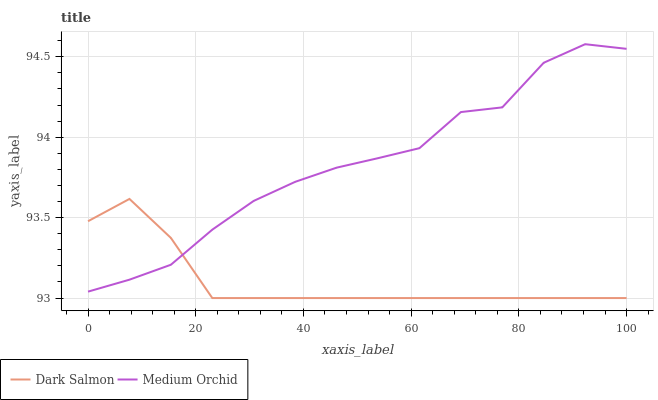Does Dark Salmon have the minimum area under the curve?
Answer yes or no. Yes. Does Medium Orchid have the maximum area under the curve?
Answer yes or no. Yes. Does Dark Salmon have the maximum area under the curve?
Answer yes or no. No. Is Dark Salmon the smoothest?
Answer yes or no. Yes. Is Medium Orchid the roughest?
Answer yes or no. Yes. Is Dark Salmon the roughest?
Answer yes or no. No. Does Dark Salmon have the lowest value?
Answer yes or no. Yes. Does Medium Orchid have the highest value?
Answer yes or no. Yes. Does Dark Salmon have the highest value?
Answer yes or no. No. Does Medium Orchid intersect Dark Salmon?
Answer yes or no. Yes. Is Medium Orchid less than Dark Salmon?
Answer yes or no. No. Is Medium Orchid greater than Dark Salmon?
Answer yes or no. No. 